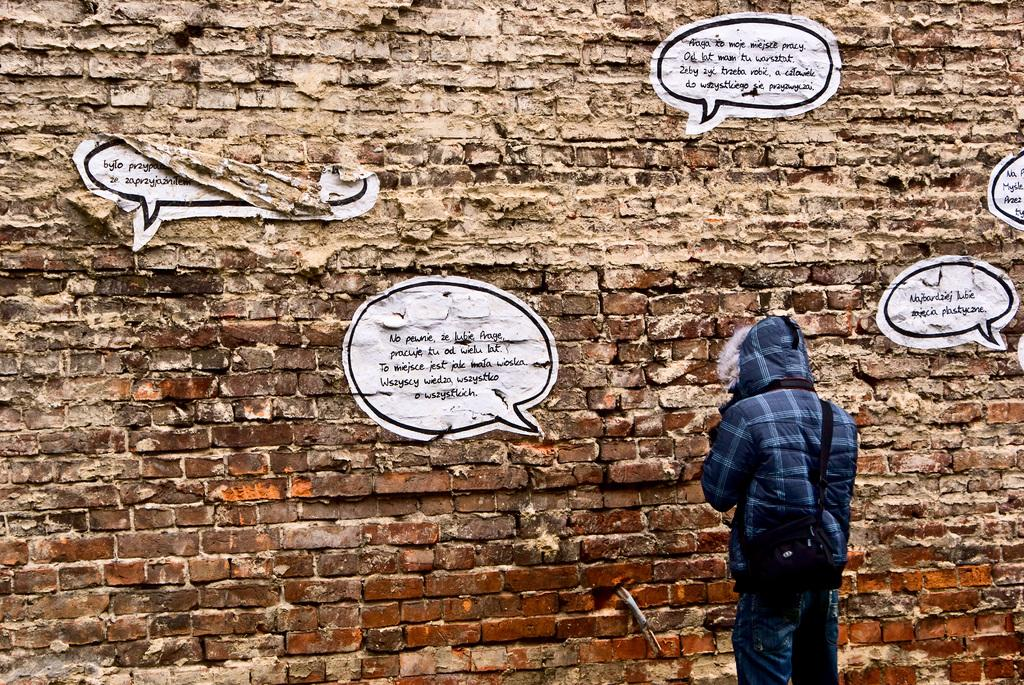Who is present on the right side of the image? There is a person on the right side of the image. What is the person wearing? The person is wearing a bag. Where is the person standing? The person is standing near a brick wall. What can be seen on the brick wall? There are posts with text on the wall. What type of mist can be seen in the scene in the image? There is no mist present in the image; it is a person standing near a brick wall with posts and text on the wall. 